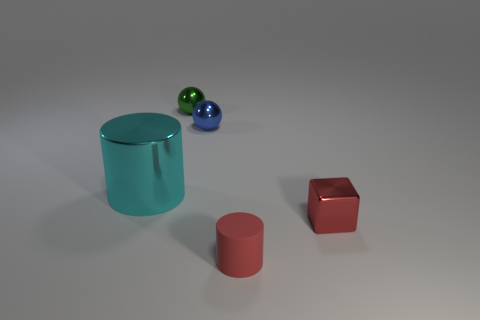What is the size of the cylinder that is in front of the big cyan metallic cylinder?
Give a very brief answer. Small. The cylinder right of the object that is behind the blue thing is made of what material?
Your answer should be compact. Rubber. What number of small metallic spheres are behind the metal sphere in front of the sphere to the left of the tiny blue ball?
Offer a terse response. 1. Is the cylinder that is in front of the big cylinder made of the same material as the small green sphere that is behind the tiny matte object?
Offer a terse response. No. There is a tiny block that is the same color as the tiny matte cylinder; what is its material?
Your answer should be compact. Metal. What number of big brown shiny things have the same shape as the blue metal thing?
Your response must be concise. 0. Is the number of green objects that are to the left of the tiny blue ball greater than the number of blue metal blocks?
Offer a very short reply. Yes. There is a tiny matte thing that is in front of the small metal ball that is behind the sphere in front of the green shiny sphere; what shape is it?
Your answer should be very brief. Cylinder. There is a metallic thing that is on the left side of the small green metallic object; is it the same shape as the tiny red object that is in front of the red block?
Offer a very short reply. Yes. Is there anything else that is the same size as the cyan cylinder?
Offer a very short reply. No. 